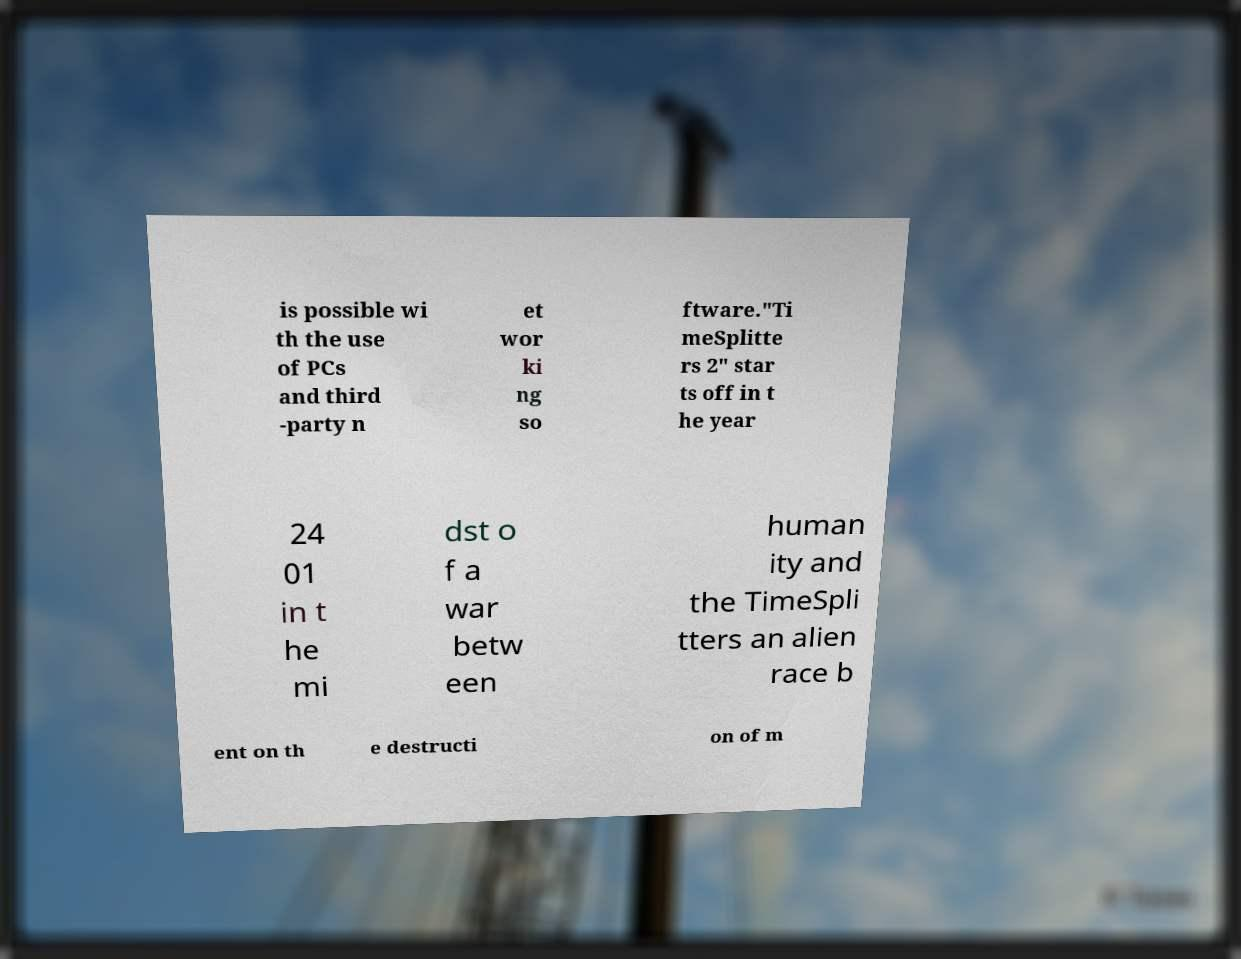For documentation purposes, I need the text within this image transcribed. Could you provide that? is possible wi th the use of PCs and third -party n et wor ki ng so ftware."Ti meSplitte rs 2" star ts off in t he year 24 01 in t he mi dst o f a war betw een human ity and the TimeSpli tters an alien race b ent on th e destructi on of m 